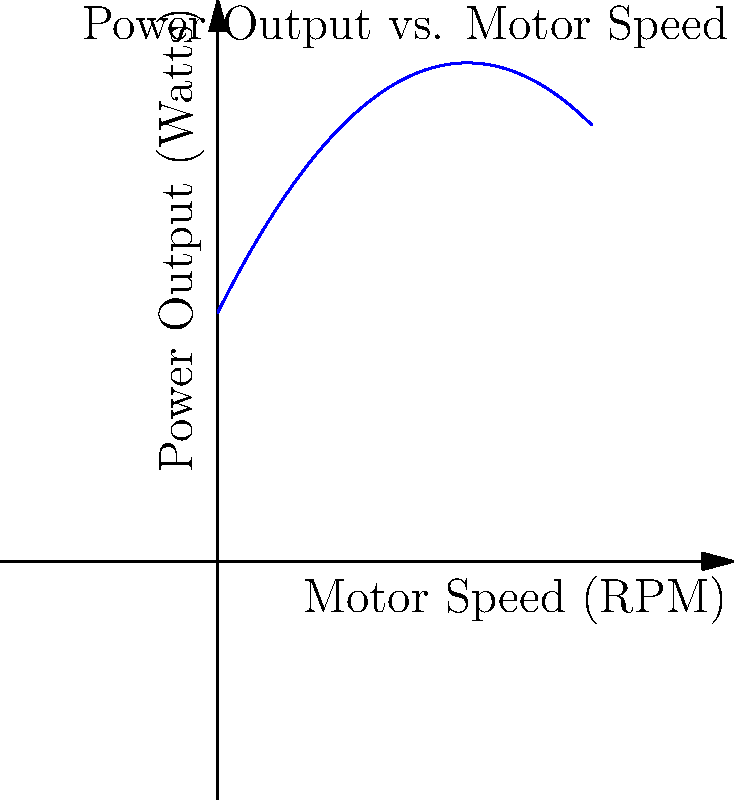A combat robot's motor power output (P) in watts is related to its rotational speed (S) in RPM by the quadratic function $P = -0.01S^2 + 2S + 100$. At what motor speed does the robot achieve maximum power output, and what is this maximum power? To find the maximum power output and the corresponding motor speed, we need to follow these steps:

1) The given function is a quadratic equation in the form $P = -0.01S^2 + 2S + 100$.

2) For a quadratic function $f(x) = ax^2 + bx + c$, the x-coordinate of the vertex represents the point where the function reaches its maximum (if $a < 0$) or minimum (if $a > 0$).

3) The formula for the x-coordinate of the vertex is $x = -\frac{b}{2a}$.

4) In our case, $a = -0.01$, $b = 2$, and $c = 100$.

5) Substituting these values:
   $S = -\frac{2}{2(-0.01)} = -\frac{2}{-0.02} = 100$ RPM

6) To find the maximum power, we substitute this S value back into the original equation:
   $P = -0.01(100)^2 + 2(100) + 100$
   $= -100 + 200 + 100$
   $= 200$ watts

Therefore, the maximum power output is 200 watts, achieved at a motor speed of 100 RPM.
Answer: 100 RPM, 200 watts 